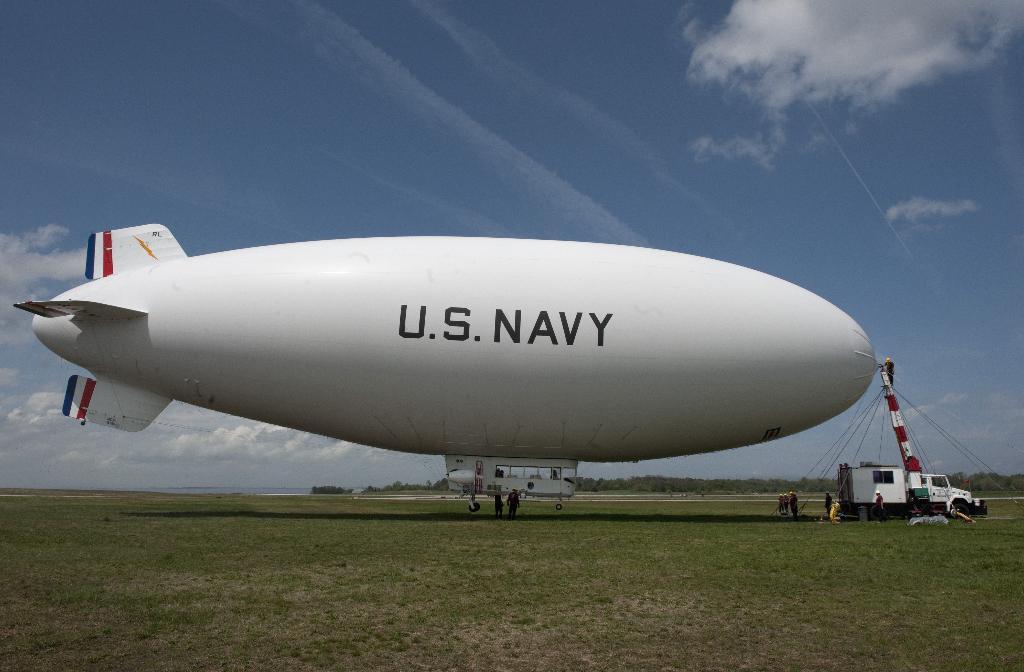What branch of the military is written on the blimp?
Make the answer very short. Navy. 